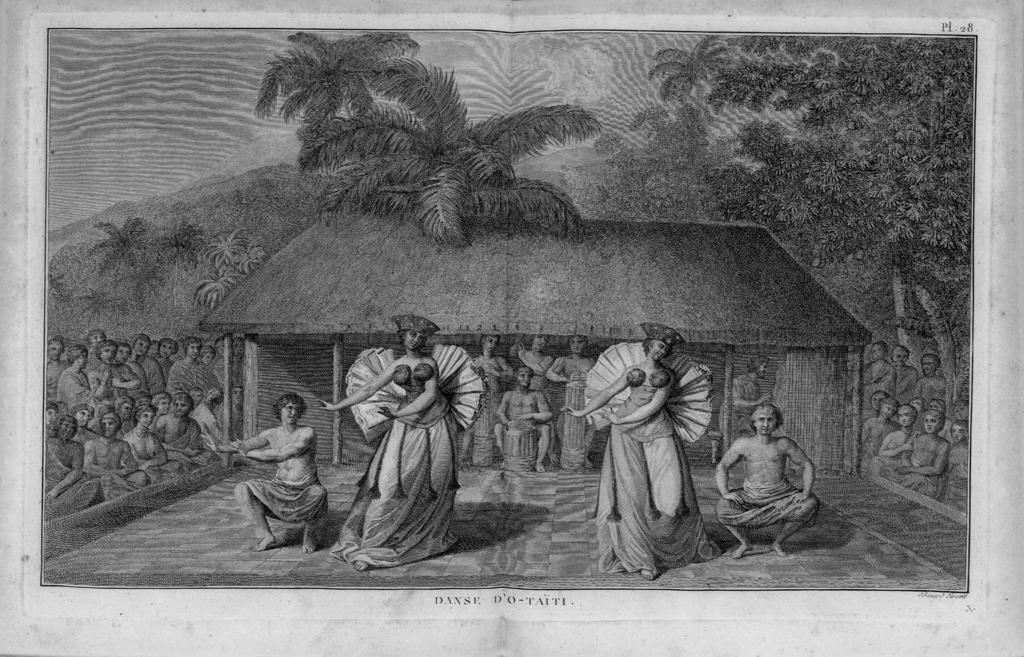What is the color scheme of the image? The image is a black and white color painting. Can you describe the style of the image? The image is a painting, and it is in black and white. What type of soda is being served by the grandmother in the image? There is no grandmother or soda present in the image, as it is a black and white color painting. 